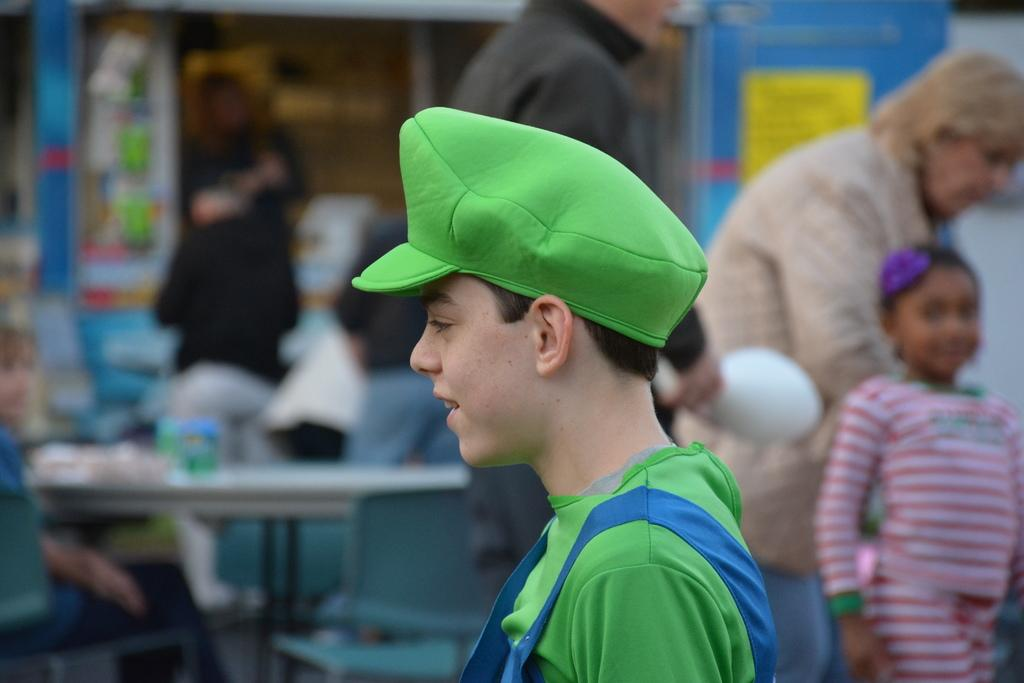How many people are in the image? There are people in the image, but the exact number is not specified. Can you describe any specific clothing item worn by someone in the image? Yes, there is a person wearing a cap in the image. What type of establishment can be seen in the background of the image? There is a store visible in the background of the image. What color is the object in the background of the image? There is a yellow colored object in the background of the image. What type of nerve is visible in the image? There is no nerve visible in the image. How many eggs are present in the image? There is no mention of eggs in the image. 